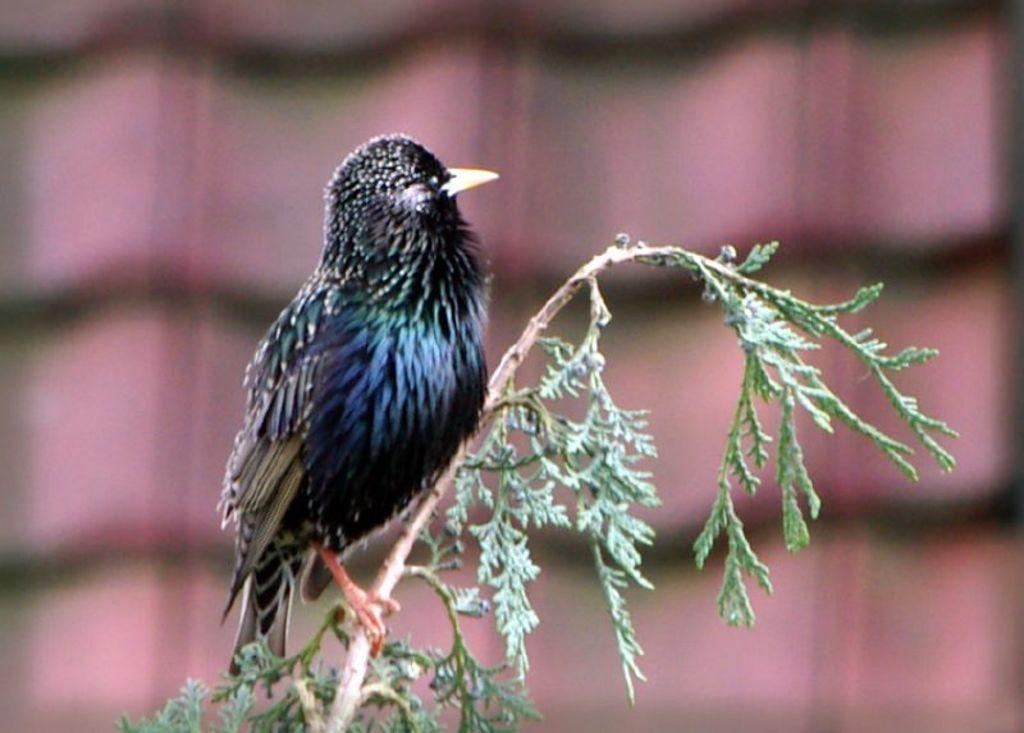What type of animal can be seen in the image? There is a bird in the image. What colors are present on the bird? The bird is black and blue in color. Where is the bird located in the image? The bird is on the branch of a tree. How would you describe the background of the image? The background of the image is pink and blurred. Can you see a cart in the image? There is no cart present in the image. Is there a cat visible in the image? There is no cat present in the image. 